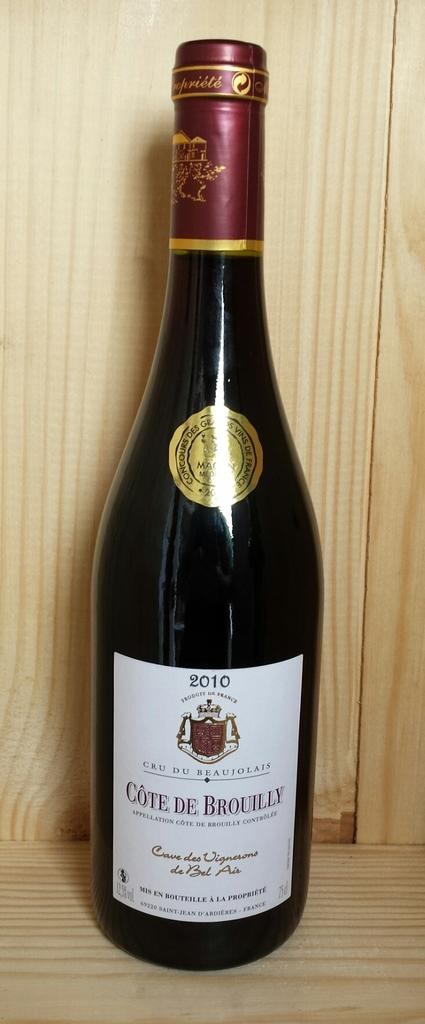<image>
Describe the image concisely. A bottle has the year 2010 on the label as well as a gold seal. 